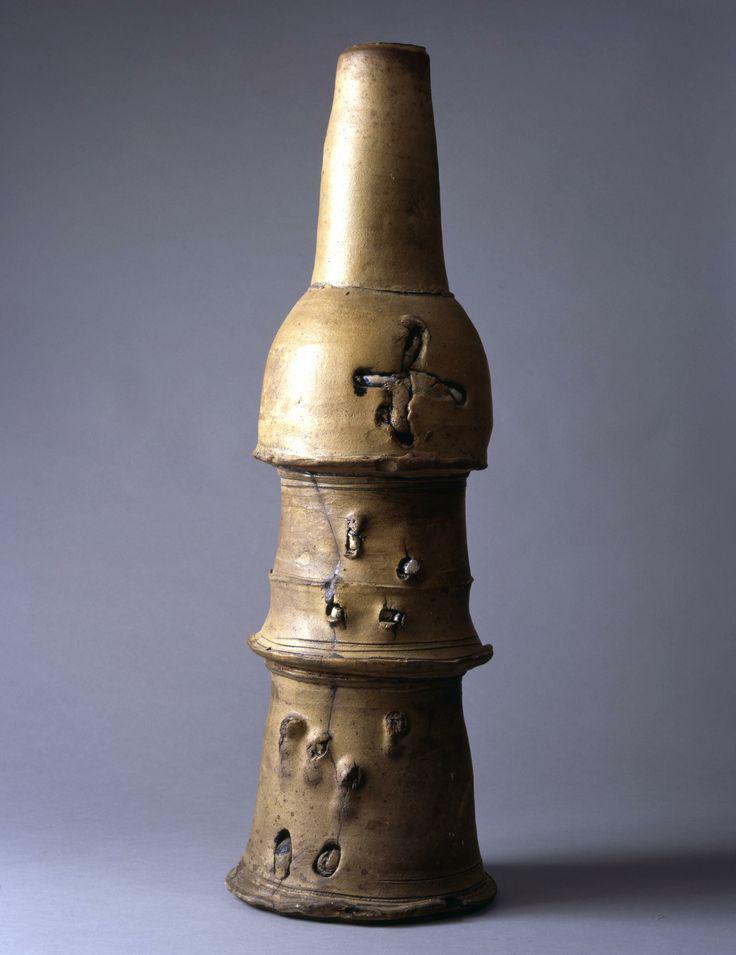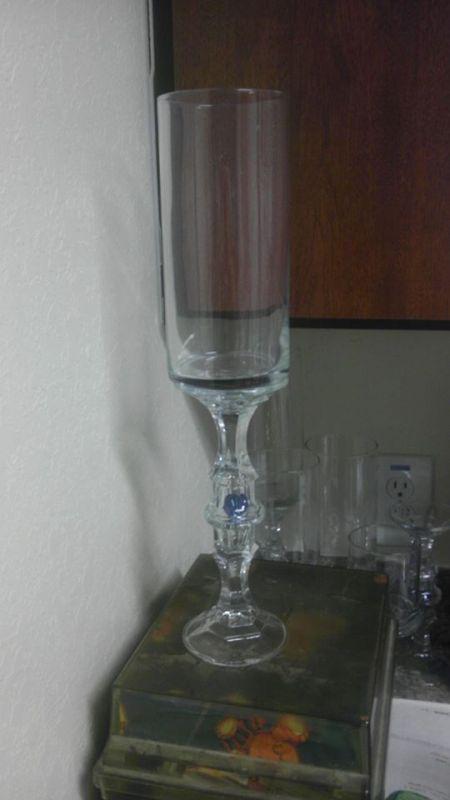The first image is the image on the left, the second image is the image on the right. Assess this claim about the two images: "the hole in the top of the vase is visible". Correct or not? Answer yes or no. No. 